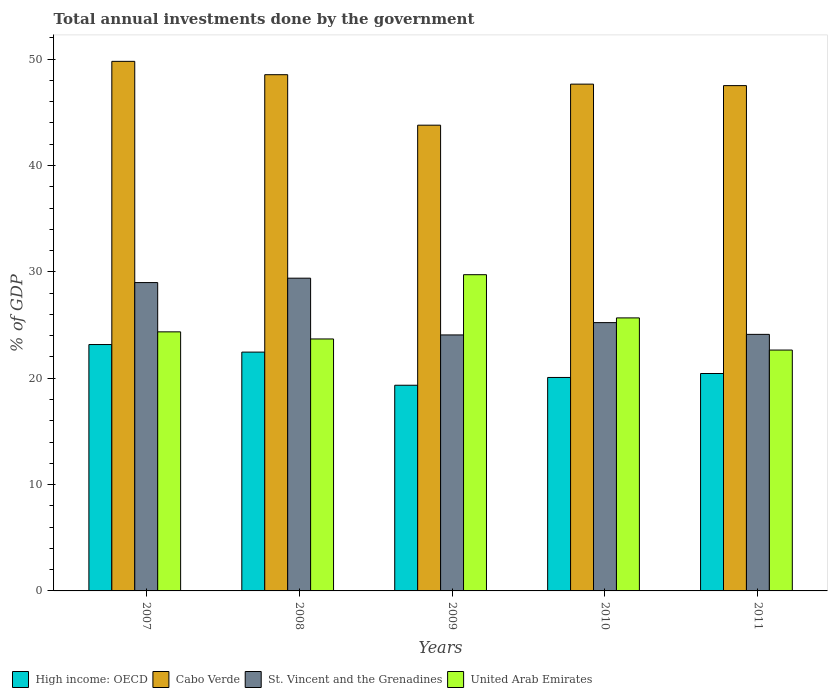How many different coloured bars are there?
Your response must be concise. 4. Are the number of bars per tick equal to the number of legend labels?
Offer a very short reply. Yes. How many bars are there on the 5th tick from the right?
Offer a terse response. 4. What is the label of the 4th group of bars from the left?
Provide a succinct answer. 2010. In how many cases, is the number of bars for a given year not equal to the number of legend labels?
Your answer should be compact. 0. What is the total annual investments done by the government in United Arab Emirates in 2010?
Offer a terse response. 25.67. Across all years, what is the maximum total annual investments done by the government in Cabo Verde?
Make the answer very short. 49.79. Across all years, what is the minimum total annual investments done by the government in Cabo Verde?
Your answer should be compact. 43.79. In which year was the total annual investments done by the government in United Arab Emirates minimum?
Offer a terse response. 2011. What is the total total annual investments done by the government in St. Vincent and the Grenadines in the graph?
Ensure brevity in your answer.  131.81. What is the difference between the total annual investments done by the government in High income: OECD in 2007 and that in 2010?
Provide a succinct answer. 3.1. What is the difference between the total annual investments done by the government in High income: OECD in 2007 and the total annual investments done by the government in St. Vincent and the Grenadines in 2010?
Provide a short and direct response. -2.06. What is the average total annual investments done by the government in Cabo Verde per year?
Give a very brief answer. 47.45. In the year 2010, what is the difference between the total annual investments done by the government in High income: OECD and total annual investments done by the government in Cabo Verde?
Offer a terse response. -27.58. What is the ratio of the total annual investments done by the government in Cabo Verde in 2008 to that in 2009?
Give a very brief answer. 1.11. What is the difference between the highest and the second highest total annual investments done by the government in High income: OECD?
Your response must be concise. 0.71. What is the difference between the highest and the lowest total annual investments done by the government in Cabo Verde?
Make the answer very short. 6. Is it the case that in every year, the sum of the total annual investments done by the government in United Arab Emirates and total annual investments done by the government in High income: OECD is greater than the sum of total annual investments done by the government in Cabo Verde and total annual investments done by the government in St. Vincent and the Grenadines?
Give a very brief answer. No. What does the 2nd bar from the left in 2009 represents?
Make the answer very short. Cabo Verde. What does the 4th bar from the right in 2008 represents?
Ensure brevity in your answer.  High income: OECD. How many bars are there?
Make the answer very short. 20. Are all the bars in the graph horizontal?
Ensure brevity in your answer.  No. Does the graph contain any zero values?
Ensure brevity in your answer.  No. Does the graph contain grids?
Ensure brevity in your answer.  No. How many legend labels are there?
Your answer should be very brief. 4. What is the title of the graph?
Provide a short and direct response. Total annual investments done by the government. Does "Guinea" appear as one of the legend labels in the graph?
Make the answer very short. No. What is the label or title of the Y-axis?
Your answer should be compact. % of GDP. What is the % of GDP in High income: OECD in 2007?
Your answer should be very brief. 23.17. What is the % of GDP of Cabo Verde in 2007?
Provide a short and direct response. 49.79. What is the % of GDP of St. Vincent and the Grenadines in 2007?
Provide a short and direct response. 28.99. What is the % of GDP in United Arab Emirates in 2007?
Ensure brevity in your answer.  24.36. What is the % of GDP in High income: OECD in 2008?
Keep it short and to the point. 22.45. What is the % of GDP of Cabo Verde in 2008?
Your answer should be very brief. 48.54. What is the % of GDP in St. Vincent and the Grenadines in 2008?
Your answer should be compact. 29.4. What is the % of GDP of United Arab Emirates in 2008?
Offer a very short reply. 23.69. What is the % of GDP of High income: OECD in 2009?
Give a very brief answer. 19.34. What is the % of GDP in Cabo Verde in 2009?
Offer a terse response. 43.79. What is the % of GDP of St. Vincent and the Grenadines in 2009?
Make the answer very short. 24.07. What is the % of GDP in United Arab Emirates in 2009?
Keep it short and to the point. 29.73. What is the % of GDP in High income: OECD in 2010?
Offer a very short reply. 20.07. What is the % of GDP of Cabo Verde in 2010?
Make the answer very short. 47.65. What is the % of GDP of St. Vincent and the Grenadines in 2010?
Offer a very short reply. 25.23. What is the % of GDP in United Arab Emirates in 2010?
Keep it short and to the point. 25.67. What is the % of GDP of High income: OECD in 2011?
Give a very brief answer. 20.44. What is the % of GDP of Cabo Verde in 2011?
Your response must be concise. 47.51. What is the % of GDP in St. Vincent and the Grenadines in 2011?
Provide a short and direct response. 24.12. What is the % of GDP of United Arab Emirates in 2011?
Keep it short and to the point. 22.65. Across all years, what is the maximum % of GDP in High income: OECD?
Give a very brief answer. 23.17. Across all years, what is the maximum % of GDP in Cabo Verde?
Ensure brevity in your answer.  49.79. Across all years, what is the maximum % of GDP of St. Vincent and the Grenadines?
Offer a very short reply. 29.4. Across all years, what is the maximum % of GDP of United Arab Emirates?
Keep it short and to the point. 29.73. Across all years, what is the minimum % of GDP of High income: OECD?
Provide a succinct answer. 19.34. Across all years, what is the minimum % of GDP in Cabo Verde?
Keep it short and to the point. 43.79. Across all years, what is the minimum % of GDP in St. Vincent and the Grenadines?
Your answer should be very brief. 24.07. Across all years, what is the minimum % of GDP in United Arab Emirates?
Ensure brevity in your answer.  22.65. What is the total % of GDP in High income: OECD in the graph?
Ensure brevity in your answer.  105.47. What is the total % of GDP of Cabo Verde in the graph?
Your answer should be compact. 237.27. What is the total % of GDP in St. Vincent and the Grenadines in the graph?
Your response must be concise. 131.81. What is the total % of GDP of United Arab Emirates in the graph?
Keep it short and to the point. 126.09. What is the difference between the % of GDP in High income: OECD in 2007 and that in 2008?
Give a very brief answer. 0.71. What is the difference between the % of GDP of Cabo Verde in 2007 and that in 2008?
Offer a terse response. 1.25. What is the difference between the % of GDP of St. Vincent and the Grenadines in 2007 and that in 2008?
Your answer should be very brief. -0.41. What is the difference between the % of GDP in United Arab Emirates in 2007 and that in 2008?
Make the answer very short. 0.67. What is the difference between the % of GDP of High income: OECD in 2007 and that in 2009?
Ensure brevity in your answer.  3.83. What is the difference between the % of GDP of Cabo Verde in 2007 and that in 2009?
Offer a very short reply. 6. What is the difference between the % of GDP in St. Vincent and the Grenadines in 2007 and that in 2009?
Provide a succinct answer. 4.92. What is the difference between the % of GDP in United Arab Emirates in 2007 and that in 2009?
Give a very brief answer. -5.37. What is the difference between the % of GDP in High income: OECD in 2007 and that in 2010?
Ensure brevity in your answer.  3.1. What is the difference between the % of GDP of Cabo Verde in 2007 and that in 2010?
Offer a very short reply. 2.14. What is the difference between the % of GDP of St. Vincent and the Grenadines in 2007 and that in 2010?
Keep it short and to the point. 3.77. What is the difference between the % of GDP of United Arab Emirates in 2007 and that in 2010?
Offer a terse response. -1.31. What is the difference between the % of GDP of High income: OECD in 2007 and that in 2011?
Give a very brief answer. 2.72. What is the difference between the % of GDP in Cabo Verde in 2007 and that in 2011?
Your answer should be compact. 2.28. What is the difference between the % of GDP of St. Vincent and the Grenadines in 2007 and that in 2011?
Ensure brevity in your answer.  4.87. What is the difference between the % of GDP of United Arab Emirates in 2007 and that in 2011?
Offer a very short reply. 1.71. What is the difference between the % of GDP of High income: OECD in 2008 and that in 2009?
Give a very brief answer. 3.12. What is the difference between the % of GDP in Cabo Verde in 2008 and that in 2009?
Keep it short and to the point. 4.75. What is the difference between the % of GDP in St. Vincent and the Grenadines in 2008 and that in 2009?
Give a very brief answer. 5.34. What is the difference between the % of GDP in United Arab Emirates in 2008 and that in 2009?
Your answer should be very brief. -6.04. What is the difference between the % of GDP in High income: OECD in 2008 and that in 2010?
Make the answer very short. 2.38. What is the difference between the % of GDP in Cabo Verde in 2008 and that in 2010?
Your answer should be compact. 0.89. What is the difference between the % of GDP in St. Vincent and the Grenadines in 2008 and that in 2010?
Give a very brief answer. 4.18. What is the difference between the % of GDP of United Arab Emirates in 2008 and that in 2010?
Offer a very short reply. -1.98. What is the difference between the % of GDP of High income: OECD in 2008 and that in 2011?
Your answer should be compact. 2.01. What is the difference between the % of GDP of Cabo Verde in 2008 and that in 2011?
Provide a short and direct response. 1.03. What is the difference between the % of GDP in St. Vincent and the Grenadines in 2008 and that in 2011?
Provide a succinct answer. 5.28. What is the difference between the % of GDP in United Arab Emirates in 2008 and that in 2011?
Offer a very short reply. 1.04. What is the difference between the % of GDP in High income: OECD in 2009 and that in 2010?
Offer a very short reply. -0.73. What is the difference between the % of GDP in Cabo Verde in 2009 and that in 2010?
Provide a short and direct response. -3.86. What is the difference between the % of GDP in St. Vincent and the Grenadines in 2009 and that in 2010?
Your answer should be compact. -1.16. What is the difference between the % of GDP of United Arab Emirates in 2009 and that in 2010?
Offer a terse response. 4.06. What is the difference between the % of GDP in High income: OECD in 2009 and that in 2011?
Provide a succinct answer. -1.1. What is the difference between the % of GDP of Cabo Verde in 2009 and that in 2011?
Your answer should be compact. -3.72. What is the difference between the % of GDP of St. Vincent and the Grenadines in 2009 and that in 2011?
Your answer should be very brief. -0.05. What is the difference between the % of GDP of United Arab Emirates in 2009 and that in 2011?
Ensure brevity in your answer.  7.09. What is the difference between the % of GDP in High income: OECD in 2010 and that in 2011?
Your answer should be very brief. -0.37. What is the difference between the % of GDP of Cabo Verde in 2010 and that in 2011?
Offer a terse response. 0.14. What is the difference between the % of GDP in St. Vincent and the Grenadines in 2010 and that in 2011?
Ensure brevity in your answer.  1.1. What is the difference between the % of GDP of United Arab Emirates in 2010 and that in 2011?
Your response must be concise. 3.02. What is the difference between the % of GDP in High income: OECD in 2007 and the % of GDP in Cabo Verde in 2008?
Keep it short and to the point. -25.37. What is the difference between the % of GDP in High income: OECD in 2007 and the % of GDP in St. Vincent and the Grenadines in 2008?
Provide a short and direct response. -6.24. What is the difference between the % of GDP in High income: OECD in 2007 and the % of GDP in United Arab Emirates in 2008?
Offer a very short reply. -0.52. What is the difference between the % of GDP in Cabo Verde in 2007 and the % of GDP in St. Vincent and the Grenadines in 2008?
Your response must be concise. 20.39. What is the difference between the % of GDP in Cabo Verde in 2007 and the % of GDP in United Arab Emirates in 2008?
Keep it short and to the point. 26.1. What is the difference between the % of GDP of St. Vincent and the Grenadines in 2007 and the % of GDP of United Arab Emirates in 2008?
Your response must be concise. 5.3. What is the difference between the % of GDP in High income: OECD in 2007 and the % of GDP in Cabo Verde in 2009?
Give a very brief answer. -20.62. What is the difference between the % of GDP of High income: OECD in 2007 and the % of GDP of St. Vincent and the Grenadines in 2009?
Give a very brief answer. -0.9. What is the difference between the % of GDP of High income: OECD in 2007 and the % of GDP of United Arab Emirates in 2009?
Offer a terse response. -6.57. What is the difference between the % of GDP in Cabo Verde in 2007 and the % of GDP in St. Vincent and the Grenadines in 2009?
Offer a terse response. 25.72. What is the difference between the % of GDP in Cabo Verde in 2007 and the % of GDP in United Arab Emirates in 2009?
Make the answer very short. 20.06. What is the difference between the % of GDP of St. Vincent and the Grenadines in 2007 and the % of GDP of United Arab Emirates in 2009?
Your response must be concise. -0.74. What is the difference between the % of GDP of High income: OECD in 2007 and the % of GDP of Cabo Verde in 2010?
Keep it short and to the point. -24.48. What is the difference between the % of GDP of High income: OECD in 2007 and the % of GDP of St. Vincent and the Grenadines in 2010?
Offer a terse response. -2.06. What is the difference between the % of GDP of High income: OECD in 2007 and the % of GDP of United Arab Emirates in 2010?
Give a very brief answer. -2.5. What is the difference between the % of GDP in Cabo Verde in 2007 and the % of GDP in St. Vincent and the Grenadines in 2010?
Provide a short and direct response. 24.56. What is the difference between the % of GDP in Cabo Verde in 2007 and the % of GDP in United Arab Emirates in 2010?
Provide a succinct answer. 24.12. What is the difference between the % of GDP of St. Vincent and the Grenadines in 2007 and the % of GDP of United Arab Emirates in 2010?
Keep it short and to the point. 3.32. What is the difference between the % of GDP of High income: OECD in 2007 and the % of GDP of Cabo Verde in 2011?
Give a very brief answer. -24.34. What is the difference between the % of GDP in High income: OECD in 2007 and the % of GDP in St. Vincent and the Grenadines in 2011?
Make the answer very short. -0.96. What is the difference between the % of GDP in High income: OECD in 2007 and the % of GDP in United Arab Emirates in 2011?
Keep it short and to the point. 0.52. What is the difference between the % of GDP in Cabo Verde in 2007 and the % of GDP in St. Vincent and the Grenadines in 2011?
Your response must be concise. 25.67. What is the difference between the % of GDP in Cabo Verde in 2007 and the % of GDP in United Arab Emirates in 2011?
Offer a terse response. 27.14. What is the difference between the % of GDP in St. Vincent and the Grenadines in 2007 and the % of GDP in United Arab Emirates in 2011?
Provide a succinct answer. 6.34. What is the difference between the % of GDP in High income: OECD in 2008 and the % of GDP in Cabo Verde in 2009?
Ensure brevity in your answer.  -21.34. What is the difference between the % of GDP in High income: OECD in 2008 and the % of GDP in St. Vincent and the Grenadines in 2009?
Your answer should be very brief. -1.61. What is the difference between the % of GDP of High income: OECD in 2008 and the % of GDP of United Arab Emirates in 2009?
Make the answer very short. -7.28. What is the difference between the % of GDP in Cabo Verde in 2008 and the % of GDP in St. Vincent and the Grenadines in 2009?
Your answer should be compact. 24.47. What is the difference between the % of GDP in Cabo Verde in 2008 and the % of GDP in United Arab Emirates in 2009?
Ensure brevity in your answer.  18.8. What is the difference between the % of GDP of St. Vincent and the Grenadines in 2008 and the % of GDP of United Arab Emirates in 2009?
Give a very brief answer. -0.33. What is the difference between the % of GDP of High income: OECD in 2008 and the % of GDP of Cabo Verde in 2010?
Ensure brevity in your answer.  -25.19. What is the difference between the % of GDP of High income: OECD in 2008 and the % of GDP of St. Vincent and the Grenadines in 2010?
Your response must be concise. -2.77. What is the difference between the % of GDP of High income: OECD in 2008 and the % of GDP of United Arab Emirates in 2010?
Your answer should be very brief. -3.22. What is the difference between the % of GDP of Cabo Verde in 2008 and the % of GDP of St. Vincent and the Grenadines in 2010?
Your response must be concise. 23.31. What is the difference between the % of GDP in Cabo Verde in 2008 and the % of GDP in United Arab Emirates in 2010?
Ensure brevity in your answer.  22.87. What is the difference between the % of GDP of St. Vincent and the Grenadines in 2008 and the % of GDP of United Arab Emirates in 2010?
Your answer should be very brief. 3.73. What is the difference between the % of GDP in High income: OECD in 2008 and the % of GDP in Cabo Verde in 2011?
Provide a succinct answer. -25.06. What is the difference between the % of GDP in High income: OECD in 2008 and the % of GDP in St. Vincent and the Grenadines in 2011?
Your answer should be very brief. -1.67. What is the difference between the % of GDP of High income: OECD in 2008 and the % of GDP of United Arab Emirates in 2011?
Offer a terse response. -0.19. What is the difference between the % of GDP of Cabo Verde in 2008 and the % of GDP of St. Vincent and the Grenadines in 2011?
Provide a short and direct response. 24.41. What is the difference between the % of GDP of Cabo Verde in 2008 and the % of GDP of United Arab Emirates in 2011?
Your answer should be compact. 25.89. What is the difference between the % of GDP in St. Vincent and the Grenadines in 2008 and the % of GDP in United Arab Emirates in 2011?
Make the answer very short. 6.76. What is the difference between the % of GDP of High income: OECD in 2009 and the % of GDP of Cabo Verde in 2010?
Your answer should be compact. -28.31. What is the difference between the % of GDP in High income: OECD in 2009 and the % of GDP in St. Vincent and the Grenadines in 2010?
Offer a terse response. -5.89. What is the difference between the % of GDP of High income: OECD in 2009 and the % of GDP of United Arab Emirates in 2010?
Offer a terse response. -6.33. What is the difference between the % of GDP of Cabo Verde in 2009 and the % of GDP of St. Vincent and the Grenadines in 2010?
Ensure brevity in your answer.  18.56. What is the difference between the % of GDP in Cabo Verde in 2009 and the % of GDP in United Arab Emirates in 2010?
Give a very brief answer. 18.12. What is the difference between the % of GDP in St. Vincent and the Grenadines in 2009 and the % of GDP in United Arab Emirates in 2010?
Provide a short and direct response. -1.6. What is the difference between the % of GDP in High income: OECD in 2009 and the % of GDP in Cabo Verde in 2011?
Provide a short and direct response. -28.17. What is the difference between the % of GDP of High income: OECD in 2009 and the % of GDP of St. Vincent and the Grenadines in 2011?
Your answer should be very brief. -4.78. What is the difference between the % of GDP of High income: OECD in 2009 and the % of GDP of United Arab Emirates in 2011?
Offer a terse response. -3.31. What is the difference between the % of GDP of Cabo Verde in 2009 and the % of GDP of St. Vincent and the Grenadines in 2011?
Make the answer very short. 19.67. What is the difference between the % of GDP of Cabo Verde in 2009 and the % of GDP of United Arab Emirates in 2011?
Make the answer very short. 21.14. What is the difference between the % of GDP of St. Vincent and the Grenadines in 2009 and the % of GDP of United Arab Emirates in 2011?
Make the answer very short. 1.42. What is the difference between the % of GDP in High income: OECD in 2010 and the % of GDP in Cabo Verde in 2011?
Offer a terse response. -27.44. What is the difference between the % of GDP in High income: OECD in 2010 and the % of GDP in St. Vincent and the Grenadines in 2011?
Ensure brevity in your answer.  -4.05. What is the difference between the % of GDP in High income: OECD in 2010 and the % of GDP in United Arab Emirates in 2011?
Provide a succinct answer. -2.58. What is the difference between the % of GDP of Cabo Verde in 2010 and the % of GDP of St. Vincent and the Grenadines in 2011?
Provide a short and direct response. 23.53. What is the difference between the % of GDP of Cabo Verde in 2010 and the % of GDP of United Arab Emirates in 2011?
Keep it short and to the point. 25. What is the difference between the % of GDP of St. Vincent and the Grenadines in 2010 and the % of GDP of United Arab Emirates in 2011?
Your response must be concise. 2.58. What is the average % of GDP of High income: OECD per year?
Give a very brief answer. 21.09. What is the average % of GDP in Cabo Verde per year?
Offer a very short reply. 47.45. What is the average % of GDP in St. Vincent and the Grenadines per year?
Your answer should be compact. 26.36. What is the average % of GDP of United Arab Emirates per year?
Offer a very short reply. 25.22. In the year 2007, what is the difference between the % of GDP of High income: OECD and % of GDP of Cabo Verde?
Your answer should be compact. -26.62. In the year 2007, what is the difference between the % of GDP in High income: OECD and % of GDP in St. Vincent and the Grenadines?
Your answer should be compact. -5.83. In the year 2007, what is the difference between the % of GDP in High income: OECD and % of GDP in United Arab Emirates?
Provide a succinct answer. -1.19. In the year 2007, what is the difference between the % of GDP of Cabo Verde and % of GDP of St. Vincent and the Grenadines?
Your answer should be very brief. 20.8. In the year 2007, what is the difference between the % of GDP of Cabo Verde and % of GDP of United Arab Emirates?
Your response must be concise. 25.43. In the year 2007, what is the difference between the % of GDP of St. Vincent and the Grenadines and % of GDP of United Arab Emirates?
Ensure brevity in your answer.  4.63. In the year 2008, what is the difference between the % of GDP of High income: OECD and % of GDP of Cabo Verde?
Ensure brevity in your answer.  -26.08. In the year 2008, what is the difference between the % of GDP of High income: OECD and % of GDP of St. Vincent and the Grenadines?
Offer a very short reply. -6.95. In the year 2008, what is the difference between the % of GDP of High income: OECD and % of GDP of United Arab Emirates?
Provide a short and direct response. -1.24. In the year 2008, what is the difference between the % of GDP of Cabo Verde and % of GDP of St. Vincent and the Grenadines?
Your answer should be very brief. 19.13. In the year 2008, what is the difference between the % of GDP of Cabo Verde and % of GDP of United Arab Emirates?
Provide a succinct answer. 24.85. In the year 2008, what is the difference between the % of GDP of St. Vincent and the Grenadines and % of GDP of United Arab Emirates?
Ensure brevity in your answer.  5.71. In the year 2009, what is the difference between the % of GDP in High income: OECD and % of GDP in Cabo Verde?
Make the answer very short. -24.45. In the year 2009, what is the difference between the % of GDP of High income: OECD and % of GDP of St. Vincent and the Grenadines?
Ensure brevity in your answer.  -4.73. In the year 2009, what is the difference between the % of GDP in High income: OECD and % of GDP in United Arab Emirates?
Offer a terse response. -10.39. In the year 2009, what is the difference between the % of GDP of Cabo Verde and % of GDP of St. Vincent and the Grenadines?
Provide a succinct answer. 19.72. In the year 2009, what is the difference between the % of GDP in Cabo Verde and % of GDP in United Arab Emirates?
Keep it short and to the point. 14.06. In the year 2009, what is the difference between the % of GDP in St. Vincent and the Grenadines and % of GDP in United Arab Emirates?
Your response must be concise. -5.66. In the year 2010, what is the difference between the % of GDP of High income: OECD and % of GDP of Cabo Verde?
Give a very brief answer. -27.58. In the year 2010, what is the difference between the % of GDP in High income: OECD and % of GDP in St. Vincent and the Grenadines?
Give a very brief answer. -5.16. In the year 2010, what is the difference between the % of GDP in High income: OECD and % of GDP in United Arab Emirates?
Your answer should be very brief. -5.6. In the year 2010, what is the difference between the % of GDP in Cabo Verde and % of GDP in St. Vincent and the Grenadines?
Your response must be concise. 22.42. In the year 2010, what is the difference between the % of GDP of Cabo Verde and % of GDP of United Arab Emirates?
Provide a succinct answer. 21.98. In the year 2010, what is the difference between the % of GDP in St. Vincent and the Grenadines and % of GDP in United Arab Emirates?
Make the answer very short. -0.44. In the year 2011, what is the difference between the % of GDP of High income: OECD and % of GDP of Cabo Verde?
Offer a very short reply. -27.07. In the year 2011, what is the difference between the % of GDP of High income: OECD and % of GDP of St. Vincent and the Grenadines?
Offer a terse response. -3.68. In the year 2011, what is the difference between the % of GDP of High income: OECD and % of GDP of United Arab Emirates?
Give a very brief answer. -2.2. In the year 2011, what is the difference between the % of GDP of Cabo Verde and % of GDP of St. Vincent and the Grenadines?
Provide a short and direct response. 23.39. In the year 2011, what is the difference between the % of GDP in Cabo Verde and % of GDP in United Arab Emirates?
Your answer should be compact. 24.86. In the year 2011, what is the difference between the % of GDP in St. Vincent and the Grenadines and % of GDP in United Arab Emirates?
Ensure brevity in your answer.  1.48. What is the ratio of the % of GDP of High income: OECD in 2007 to that in 2008?
Offer a terse response. 1.03. What is the ratio of the % of GDP in Cabo Verde in 2007 to that in 2008?
Keep it short and to the point. 1.03. What is the ratio of the % of GDP of United Arab Emirates in 2007 to that in 2008?
Keep it short and to the point. 1.03. What is the ratio of the % of GDP in High income: OECD in 2007 to that in 2009?
Your response must be concise. 1.2. What is the ratio of the % of GDP in Cabo Verde in 2007 to that in 2009?
Your answer should be very brief. 1.14. What is the ratio of the % of GDP of St. Vincent and the Grenadines in 2007 to that in 2009?
Give a very brief answer. 1.2. What is the ratio of the % of GDP in United Arab Emirates in 2007 to that in 2009?
Make the answer very short. 0.82. What is the ratio of the % of GDP in High income: OECD in 2007 to that in 2010?
Provide a short and direct response. 1.15. What is the ratio of the % of GDP in Cabo Verde in 2007 to that in 2010?
Make the answer very short. 1.04. What is the ratio of the % of GDP in St. Vincent and the Grenadines in 2007 to that in 2010?
Provide a short and direct response. 1.15. What is the ratio of the % of GDP of United Arab Emirates in 2007 to that in 2010?
Offer a very short reply. 0.95. What is the ratio of the % of GDP in High income: OECD in 2007 to that in 2011?
Keep it short and to the point. 1.13. What is the ratio of the % of GDP of Cabo Verde in 2007 to that in 2011?
Provide a succinct answer. 1.05. What is the ratio of the % of GDP of St. Vincent and the Grenadines in 2007 to that in 2011?
Your answer should be compact. 1.2. What is the ratio of the % of GDP of United Arab Emirates in 2007 to that in 2011?
Ensure brevity in your answer.  1.08. What is the ratio of the % of GDP of High income: OECD in 2008 to that in 2009?
Ensure brevity in your answer.  1.16. What is the ratio of the % of GDP of Cabo Verde in 2008 to that in 2009?
Your answer should be very brief. 1.11. What is the ratio of the % of GDP of St. Vincent and the Grenadines in 2008 to that in 2009?
Offer a very short reply. 1.22. What is the ratio of the % of GDP of United Arab Emirates in 2008 to that in 2009?
Provide a short and direct response. 0.8. What is the ratio of the % of GDP of High income: OECD in 2008 to that in 2010?
Provide a short and direct response. 1.12. What is the ratio of the % of GDP in Cabo Verde in 2008 to that in 2010?
Your answer should be very brief. 1.02. What is the ratio of the % of GDP in St. Vincent and the Grenadines in 2008 to that in 2010?
Make the answer very short. 1.17. What is the ratio of the % of GDP of United Arab Emirates in 2008 to that in 2010?
Offer a very short reply. 0.92. What is the ratio of the % of GDP of High income: OECD in 2008 to that in 2011?
Provide a succinct answer. 1.1. What is the ratio of the % of GDP in Cabo Verde in 2008 to that in 2011?
Provide a succinct answer. 1.02. What is the ratio of the % of GDP of St. Vincent and the Grenadines in 2008 to that in 2011?
Your response must be concise. 1.22. What is the ratio of the % of GDP of United Arab Emirates in 2008 to that in 2011?
Make the answer very short. 1.05. What is the ratio of the % of GDP in High income: OECD in 2009 to that in 2010?
Provide a short and direct response. 0.96. What is the ratio of the % of GDP in Cabo Verde in 2009 to that in 2010?
Your response must be concise. 0.92. What is the ratio of the % of GDP of St. Vincent and the Grenadines in 2009 to that in 2010?
Provide a short and direct response. 0.95. What is the ratio of the % of GDP of United Arab Emirates in 2009 to that in 2010?
Your answer should be compact. 1.16. What is the ratio of the % of GDP of High income: OECD in 2009 to that in 2011?
Make the answer very short. 0.95. What is the ratio of the % of GDP of Cabo Verde in 2009 to that in 2011?
Provide a succinct answer. 0.92. What is the ratio of the % of GDP in United Arab Emirates in 2009 to that in 2011?
Offer a very short reply. 1.31. What is the ratio of the % of GDP of High income: OECD in 2010 to that in 2011?
Keep it short and to the point. 0.98. What is the ratio of the % of GDP in Cabo Verde in 2010 to that in 2011?
Offer a very short reply. 1. What is the ratio of the % of GDP of St. Vincent and the Grenadines in 2010 to that in 2011?
Provide a succinct answer. 1.05. What is the ratio of the % of GDP in United Arab Emirates in 2010 to that in 2011?
Offer a terse response. 1.13. What is the difference between the highest and the second highest % of GDP of High income: OECD?
Offer a very short reply. 0.71. What is the difference between the highest and the second highest % of GDP of Cabo Verde?
Make the answer very short. 1.25. What is the difference between the highest and the second highest % of GDP in St. Vincent and the Grenadines?
Your response must be concise. 0.41. What is the difference between the highest and the second highest % of GDP in United Arab Emirates?
Offer a very short reply. 4.06. What is the difference between the highest and the lowest % of GDP in High income: OECD?
Offer a terse response. 3.83. What is the difference between the highest and the lowest % of GDP in Cabo Verde?
Your answer should be compact. 6. What is the difference between the highest and the lowest % of GDP of St. Vincent and the Grenadines?
Give a very brief answer. 5.34. What is the difference between the highest and the lowest % of GDP of United Arab Emirates?
Keep it short and to the point. 7.09. 